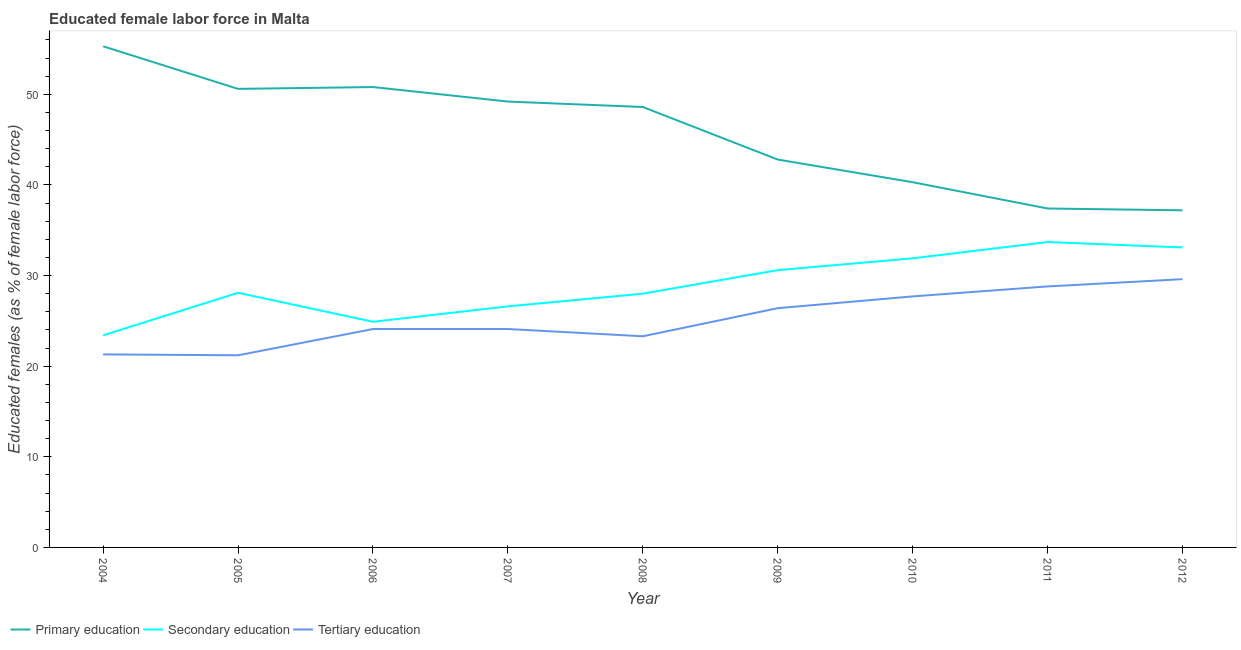Is the number of lines equal to the number of legend labels?
Your answer should be very brief. Yes. What is the percentage of female labor force who received tertiary education in 2010?
Give a very brief answer. 27.7. Across all years, what is the maximum percentage of female labor force who received primary education?
Provide a succinct answer. 55.3. Across all years, what is the minimum percentage of female labor force who received tertiary education?
Make the answer very short. 21.2. In which year was the percentage of female labor force who received primary education maximum?
Keep it short and to the point. 2004. What is the total percentage of female labor force who received tertiary education in the graph?
Make the answer very short. 226.5. What is the difference between the percentage of female labor force who received tertiary education in 2005 and that in 2011?
Provide a succinct answer. -7.6. What is the difference between the percentage of female labor force who received primary education in 2010 and the percentage of female labor force who received tertiary education in 2006?
Give a very brief answer. 16.2. What is the average percentage of female labor force who received tertiary education per year?
Your answer should be very brief. 25.17. In the year 2006, what is the difference between the percentage of female labor force who received secondary education and percentage of female labor force who received tertiary education?
Offer a very short reply. 0.8. In how many years, is the percentage of female labor force who received secondary education greater than 42 %?
Your response must be concise. 0. What is the ratio of the percentage of female labor force who received primary education in 2004 to that in 2005?
Provide a succinct answer. 1.09. Is the difference between the percentage of female labor force who received primary education in 2004 and 2005 greater than the difference between the percentage of female labor force who received secondary education in 2004 and 2005?
Your response must be concise. Yes. What is the difference between the highest and the second highest percentage of female labor force who received primary education?
Ensure brevity in your answer.  4.5. What is the difference between the highest and the lowest percentage of female labor force who received secondary education?
Make the answer very short. 10.3. Is the sum of the percentage of female labor force who received primary education in 2004 and 2010 greater than the maximum percentage of female labor force who received tertiary education across all years?
Your response must be concise. Yes. Is it the case that in every year, the sum of the percentage of female labor force who received primary education and percentage of female labor force who received secondary education is greater than the percentage of female labor force who received tertiary education?
Make the answer very short. Yes. How many years are there in the graph?
Give a very brief answer. 9. What is the difference between two consecutive major ticks on the Y-axis?
Provide a short and direct response. 10. Does the graph contain any zero values?
Provide a succinct answer. No. Does the graph contain grids?
Give a very brief answer. No. How many legend labels are there?
Your response must be concise. 3. What is the title of the graph?
Provide a short and direct response. Educated female labor force in Malta. What is the label or title of the Y-axis?
Offer a very short reply. Educated females (as % of female labor force). What is the Educated females (as % of female labor force) in Primary education in 2004?
Offer a very short reply. 55.3. What is the Educated females (as % of female labor force) of Secondary education in 2004?
Ensure brevity in your answer.  23.4. What is the Educated females (as % of female labor force) of Tertiary education in 2004?
Provide a succinct answer. 21.3. What is the Educated females (as % of female labor force) in Primary education in 2005?
Your answer should be compact. 50.6. What is the Educated females (as % of female labor force) in Secondary education in 2005?
Provide a succinct answer. 28.1. What is the Educated females (as % of female labor force) in Tertiary education in 2005?
Provide a short and direct response. 21.2. What is the Educated females (as % of female labor force) in Primary education in 2006?
Make the answer very short. 50.8. What is the Educated females (as % of female labor force) of Secondary education in 2006?
Your answer should be very brief. 24.9. What is the Educated females (as % of female labor force) in Tertiary education in 2006?
Make the answer very short. 24.1. What is the Educated females (as % of female labor force) in Primary education in 2007?
Keep it short and to the point. 49.2. What is the Educated females (as % of female labor force) of Secondary education in 2007?
Offer a terse response. 26.6. What is the Educated females (as % of female labor force) of Tertiary education in 2007?
Your response must be concise. 24.1. What is the Educated females (as % of female labor force) of Primary education in 2008?
Provide a succinct answer. 48.6. What is the Educated females (as % of female labor force) of Tertiary education in 2008?
Give a very brief answer. 23.3. What is the Educated females (as % of female labor force) of Primary education in 2009?
Ensure brevity in your answer.  42.8. What is the Educated females (as % of female labor force) in Secondary education in 2009?
Offer a very short reply. 30.6. What is the Educated females (as % of female labor force) of Tertiary education in 2009?
Your answer should be compact. 26.4. What is the Educated females (as % of female labor force) of Primary education in 2010?
Offer a very short reply. 40.3. What is the Educated females (as % of female labor force) in Secondary education in 2010?
Provide a short and direct response. 31.9. What is the Educated females (as % of female labor force) of Tertiary education in 2010?
Provide a succinct answer. 27.7. What is the Educated females (as % of female labor force) of Primary education in 2011?
Offer a terse response. 37.4. What is the Educated females (as % of female labor force) in Secondary education in 2011?
Give a very brief answer. 33.7. What is the Educated females (as % of female labor force) of Tertiary education in 2011?
Provide a short and direct response. 28.8. What is the Educated females (as % of female labor force) of Primary education in 2012?
Keep it short and to the point. 37.2. What is the Educated females (as % of female labor force) of Secondary education in 2012?
Provide a short and direct response. 33.1. What is the Educated females (as % of female labor force) in Tertiary education in 2012?
Keep it short and to the point. 29.6. Across all years, what is the maximum Educated females (as % of female labor force) in Primary education?
Ensure brevity in your answer.  55.3. Across all years, what is the maximum Educated females (as % of female labor force) in Secondary education?
Offer a terse response. 33.7. Across all years, what is the maximum Educated females (as % of female labor force) of Tertiary education?
Your answer should be compact. 29.6. Across all years, what is the minimum Educated females (as % of female labor force) in Primary education?
Offer a very short reply. 37.2. Across all years, what is the minimum Educated females (as % of female labor force) in Secondary education?
Provide a succinct answer. 23.4. Across all years, what is the minimum Educated females (as % of female labor force) of Tertiary education?
Your answer should be compact. 21.2. What is the total Educated females (as % of female labor force) of Primary education in the graph?
Offer a terse response. 412.2. What is the total Educated females (as % of female labor force) of Secondary education in the graph?
Offer a very short reply. 260.3. What is the total Educated females (as % of female labor force) of Tertiary education in the graph?
Make the answer very short. 226.5. What is the difference between the Educated females (as % of female labor force) of Primary education in 2004 and that in 2005?
Your answer should be very brief. 4.7. What is the difference between the Educated females (as % of female labor force) in Secondary education in 2004 and that in 2005?
Your answer should be very brief. -4.7. What is the difference between the Educated females (as % of female labor force) of Tertiary education in 2004 and that in 2005?
Offer a terse response. 0.1. What is the difference between the Educated females (as % of female labor force) of Primary education in 2004 and that in 2006?
Offer a very short reply. 4.5. What is the difference between the Educated females (as % of female labor force) of Tertiary education in 2004 and that in 2006?
Your answer should be very brief. -2.8. What is the difference between the Educated females (as % of female labor force) in Primary education in 2004 and that in 2007?
Your answer should be very brief. 6.1. What is the difference between the Educated females (as % of female labor force) in Secondary education in 2004 and that in 2007?
Your answer should be very brief. -3.2. What is the difference between the Educated females (as % of female labor force) in Primary education in 2004 and that in 2009?
Provide a succinct answer. 12.5. What is the difference between the Educated females (as % of female labor force) of Secondary education in 2004 and that in 2011?
Give a very brief answer. -10.3. What is the difference between the Educated females (as % of female labor force) in Primary education in 2004 and that in 2012?
Ensure brevity in your answer.  18.1. What is the difference between the Educated females (as % of female labor force) of Secondary education in 2004 and that in 2012?
Provide a succinct answer. -9.7. What is the difference between the Educated females (as % of female labor force) of Tertiary education in 2004 and that in 2012?
Offer a terse response. -8.3. What is the difference between the Educated females (as % of female labor force) in Secondary education in 2005 and that in 2006?
Provide a succinct answer. 3.2. What is the difference between the Educated females (as % of female labor force) of Tertiary education in 2005 and that in 2007?
Make the answer very short. -2.9. What is the difference between the Educated females (as % of female labor force) in Tertiary education in 2005 and that in 2008?
Give a very brief answer. -2.1. What is the difference between the Educated females (as % of female labor force) of Primary education in 2005 and that in 2009?
Keep it short and to the point. 7.8. What is the difference between the Educated females (as % of female labor force) in Secondary education in 2005 and that in 2009?
Offer a very short reply. -2.5. What is the difference between the Educated females (as % of female labor force) in Tertiary education in 2005 and that in 2009?
Provide a succinct answer. -5.2. What is the difference between the Educated females (as % of female labor force) in Primary education in 2005 and that in 2010?
Keep it short and to the point. 10.3. What is the difference between the Educated females (as % of female labor force) of Secondary education in 2005 and that in 2010?
Your answer should be very brief. -3.8. What is the difference between the Educated females (as % of female labor force) of Tertiary education in 2005 and that in 2010?
Provide a short and direct response. -6.5. What is the difference between the Educated females (as % of female labor force) in Secondary education in 2005 and that in 2012?
Ensure brevity in your answer.  -5. What is the difference between the Educated females (as % of female labor force) of Secondary education in 2006 and that in 2007?
Your response must be concise. -1.7. What is the difference between the Educated females (as % of female labor force) of Secondary education in 2006 and that in 2009?
Give a very brief answer. -5.7. What is the difference between the Educated females (as % of female labor force) in Tertiary education in 2006 and that in 2009?
Ensure brevity in your answer.  -2.3. What is the difference between the Educated females (as % of female labor force) in Primary education in 2006 and that in 2010?
Provide a short and direct response. 10.5. What is the difference between the Educated females (as % of female labor force) in Secondary education in 2006 and that in 2011?
Offer a very short reply. -8.8. What is the difference between the Educated females (as % of female labor force) in Tertiary education in 2006 and that in 2011?
Provide a succinct answer. -4.7. What is the difference between the Educated females (as % of female labor force) of Secondary education in 2006 and that in 2012?
Provide a succinct answer. -8.2. What is the difference between the Educated females (as % of female labor force) in Tertiary education in 2006 and that in 2012?
Give a very brief answer. -5.5. What is the difference between the Educated females (as % of female labor force) in Primary education in 2007 and that in 2008?
Your answer should be compact. 0.6. What is the difference between the Educated females (as % of female labor force) in Primary education in 2007 and that in 2009?
Keep it short and to the point. 6.4. What is the difference between the Educated females (as % of female labor force) in Secondary education in 2007 and that in 2009?
Offer a terse response. -4. What is the difference between the Educated females (as % of female labor force) of Tertiary education in 2007 and that in 2009?
Keep it short and to the point. -2.3. What is the difference between the Educated females (as % of female labor force) of Primary education in 2007 and that in 2010?
Make the answer very short. 8.9. What is the difference between the Educated females (as % of female labor force) of Tertiary education in 2007 and that in 2010?
Offer a very short reply. -3.6. What is the difference between the Educated females (as % of female labor force) of Secondary education in 2007 and that in 2011?
Provide a succinct answer. -7.1. What is the difference between the Educated females (as % of female labor force) of Tertiary education in 2007 and that in 2011?
Make the answer very short. -4.7. What is the difference between the Educated females (as % of female labor force) of Primary education in 2007 and that in 2012?
Your answer should be very brief. 12. What is the difference between the Educated females (as % of female labor force) of Secondary education in 2007 and that in 2012?
Offer a very short reply. -6.5. What is the difference between the Educated females (as % of female labor force) in Primary education in 2008 and that in 2009?
Provide a succinct answer. 5.8. What is the difference between the Educated females (as % of female labor force) in Secondary education in 2008 and that in 2009?
Your response must be concise. -2.6. What is the difference between the Educated females (as % of female labor force) in Secondary education in 2008 and that in 2011?
Offer a terse response. -5.7. What is the difference between the Educated females (as % of female labor force) of Tertiary education in 2008 and that in 2011?
Give a very brief answer. -5.5. What is the difference between the Educated females (as % of female labor force) in Tertiary education in 2008 and that in 2012?
Keep it short and to the point. -6.3. What is the difference between the Educated females (as % of female labor force) of Secondary education in 2009 and that in 2010?
Your answer should be compact. -1.3. What is the difference between the Educated females (as % of female labor force) of Primary education in 2009 and that in 2012?
Your response must be concise. 5.6. What is the difference between the Educated females (as % of female labor force) of Secondary education in 2009 and that in 2012?
Provide a succinct answer. -2.5. What is the difference between the Educated females (as % of female labor force) of Tertiary education in 2009 and that in 2012?
Offer a very short reply. -3.2. What is the difference between the Educated females (as % of female labor force) of Tertiary education in 2010 and that in 2011?
Offer a terse response. -1.1. What is the difference between the Educated females (as % of female labor force) of Primary education in 2010 and that in 2012?
Ensure brevity in your answer.  3.1. What is the difference between the Educated females (as % of female labor force) in Secondary education in 2010 and that in 2012?
Offer a very short reply. -1.2. What is the difference between the Educated females (as % of female labor force) of Primary education in 2011 and that in 2012?
Provide a short and direct response. 0.2. What is the difference between the Educated females (as % of female labor force) of Tertiary education in 2011 and that in 2012?
Offer a terse response. -0.8. What is the difference between the Educated females (as % of female labor force) in Primary education in 2004 and the Educated females (as % of female labor force) in Secondary education in 2005?
Your answer should be compact. 27.2. What is the difference between the Educated females (as % of female labor force) in Primary education in 2004 and the Educated females (as % of female labor force) in Tertiary education in 2005?
Your answer should be very brief. 34.1. What is the difference between the Educated females (as % of female labor force) of Primary education in 2004 and the Educated females (as % of female labor force) of Secondary education in 2006?
Your response must be concise. 30.4. What is the difference between the Educated females (as % of female labor force) of Primary education in 2004 and the Educated females (as % of female labor force) of Tertiary education in 2006?
Your answer should be very brief. 31.2. What is the difference between the Educated females (as % of female labor force) of Primary education in 2004 and the Educated females (as % of female labor force) of Secondary education in 2007?
Offer a terse response. 28.7. What is the difference between the Educated females (as % of female labor force) of Primary education in 2004 and the Educated females (as % of female labor force) of Tertiary education in 2007?
Keep it short and to the point. 31.2. What is the difference between the Educated females (as % of female labor force) in Primary education in 2004 and the Educated females (as % of female labor force) in Secondary education in 2008?
Your response must be concise. 27.3. What is the difference between the Educated females (as % of female labor force) of Primary education in 2004 and the Educated females (as % of female labor force) of Tertiary education in 2008?
Make the answer very short. 32. What is the difference between the Educated females (as % of female labor force) in Primary education in 2004 and the Educated females (as % of female labor force) in Secondary education in 2009?
Your answer should be very brief. 24.7. What is the difference between the Educated females (as % of female labor force) of Primary education in 2004 and the Educated females (as % of female labor force) of Tertiary education in 2009?
Make the answer very short. 28.9. What is the difference between the Educated females (as % of female labor force) in Primary education in 2004 and the Educated females (as % of female labor force) in Secondary education in 2010?
Your answer should be very brief. 23.4. What is the difference between the Educated females (as % of female labor force) in Primary education in 2004 and the Educated females (as % of female labor force) in Tertiary education in 2010?
Your answer should be very brief. 27.6. What is the difference between the Educated females (as % of female labor force) in Primary education in 2004 and the Educated females (as % of female labor force) in Secondary education in 2011?
Your response must be concise. 21.6. What is the difference between the Educated females (as % of female labor force) in Primary education in 2004 and the Educated females (as % of female labor force) in Tertiary education in 2011?
Your answer should be very brief. 26.5. What is the difference between the Educated females (as % of female labor force) in Primary education in 2004 and the Educated females (as % of female labor force) in Tertiary education in 2012?
Offer a very short reply. 25.7. What is the difference between the Educated females (as % of female labor force) in Secondary education in 2004 and the Educated females (as % of female labor force) in Tertiary education in 2012?
Offer a very short reply. -6.2. What is the difference between the Educated females (as % of female labor force) of Primary education in 2005 and the Educated females (as % of female labor force) of Secondary education in 2006?
Make the answer very short. 25.7. What is the difference between the Educated females (as % of female labor force) in Secondary education in 2005 and the Educated females (as % of female labor force) in Tertiary education in 2006?
Your response must be concise. 4. What is the difference between the Educated females (as % of female labor force) of Secondary education in 2005 and the Educated females (as % of female labor force) of Tertiary education in 2007?
Your response must be concise. 4. What is the difference between the Educated females (as % of female labor force) in Primary education in 2005 and the Educated females (as % of female labor force) in Secondary education in 2008?
Provide a succinct answer. 22.6. What is the difference between the Educated females (as % of female labor force) in Primary education in 2005 and the Educated females (as % of female labor force) in Tertiary education in 2008?
Your response must be concise. 27.3. What is the difference between the Educated females (as % of female labor force) of Secondary education in 2005 and the Educated females (as % of female labor force) of Tertiary education in 2008?
Ensure brevity in your answer.  4.8. What is the difference between the Educated females (as % of female labor force) in Primary education in 2005 and the Educated females (as % of female labor force) in Secondary education in 2009?
Your response must be concise. 20. What is the difference between the Educated females (as % of female labor force) in Primary education in 2005 and the Educated females (as % of female labor force) in Tertiary education in 2009?
Provide a short and direct response. 24.2. What is the difference between the Educated females (as % of female labor force) in Secondary education in 2005 and the Educated females (as % of female labor force) in Tertiary education in 2009?
Give a very brief answer. 1.7. What is the difference between the Educated females (as % of female labor force) in Primary education in 2005 and the Educated females (as % of female labor force) in Tertiary education in 2010?
Provide a succinct answer. 22.9. What is the difference between the Educated females (as % of female labor force) in Primary education in 2005 and the Educated females (as % of female labor force) in Tertiary education in 2011?
Keep it short and to the point. 21.8. What is the difference between the Educated females (as % of female labor force) in Secondary education in 2005 and the Educated females (as % of female labor force) in Tertiary education in 2011?
Provide a short and direct response. -0.7. What is the difference between the Educated females (as % of female labor force) of Secondary education in 2005 and the Educated females (as % of female labor force) of Tertiary education in 2012?
Offer a very short reply. -1.5. What is the difference between the Educated females (as % of female labor force) in Primary education in 2006 and the Educated females (as % of female labor force) in Secondary education in 2007?
Ensure brevity in your answer.  24.2. What is the difference between the Educated females (as % of female labor force) of Primary education in 2006 and the Educated females (as % of female labor force) of Tertiary education in 2007?
Your answer should be very brief. 26.7. What is the difference between the Educated females (as % of female labor force) in Secondary education in 2006 and the Educated females (as % of female labor force) in Tertiary education in 2007?
Offer a very short reply. 0.8. What is the difference between the Educated females (as % of female labor force) in Primary education in 2006 and the Educated females (as % of female labor force) in Secondary education in 2008?
Your answer should be very brief. 22.8. What is the difference between the Educated females (as % of female labor force) in Primary education in 2006 and the Educated females (as % of female labor force) in Tertiary education in 2008?
Provide a short and direct response. 27.5. What is the difference between the Educated females (as % of female labor force) in Primary education in 2006 and the Educated females (as % of female labor force) in Secondary education in 2009?
Your answer should be very brief. 20.2. What is the difference between the Educated females (as % of female labor force) of Primary education in 2006 and the Educated females (as % of female labor force) of Tertiary education in 2009?
Your answer should be very brief. 24.4. What is the difference between the Educated females (as % of female labor force) of Primary education in 2006 and the Educated females (as % of female labor force) of Tertiary education in 2010?
Ensure brevity in your answer.  23.1. What is the difference between the Educated females (as % of female labor force) in Secondary education in 2006 and the Educated females (as % of female labor force) in Tertiary education in 2011?
Your answer should be compact. -3.9. What is the difference between the Educated females (as % of female labor force) in Primary education in 2006 and the Educated females (as % of female labor force) in Secondary education in 2012?
Provide a short and direct response. 17.7. What is the difference between the Educated females (as % of female labor force) of Primary education in 2006 and the Educated females (as % of female labor force) of Tertiary education in 2012?
Make the answer very short. 21.2. What is the difference between the Educated females (as % of female labor force) of Primary education in 2007 and the Educated females (as % of female labor force) of Secondary education in 2008?
Provide a short and direct response. 21.2. What is the difference between the Educated females (as % of female labor force) in Primary education in 2007 and the Educated females (as % of female labor force) in Tertiary education in 2008?
Give a very brief answer. 25.9. What is the difference between the Educated females (as % of female labor force) of Primary education in 2007 and the Educated females (as % of female labor force) of Secondary education in 2009?
Your answer should be compact. 18.6. What is the difference between the Educated females (as % of female labor force) in Primary education in 2007 and the Educated females (as % of female labor force) in Tertiary education in 2009?
Your answer should be compact. 22.8. What is the difference between the Educated females (as % of female labor force) in Primary education in 2007 and the Educated females (as % of female labor force) in Secondary education in 2010?
Provide a short and direct response. 17.3. What is the difference between the Educated females (as % of female labor force) in Primary education in 2007 and the Educated females (as % of female labor force) in Secondary education in 2011?
Provide a succinct answer. 15.5. What is the difference between the Educated females (as % of female labor force) in Primary education in 2007 and the Educated females (as % of female labor force) in Tertiary education in 2011?
Offer a very short reply. 20.4. What is the difference between the Educated females (as % of female labor force) of Secondary education in 2007 and the Educated females (as % of female labor force) of Tertiary education in 2011?
Your response must be concise. -2.2. What is the difference between the Educated females (as % of female labor force) in Primary education in 2007 and the Educated females (as % of female labor force) in Tertiary education in 2012?
Provide a short and direct response. 19.6. What is the difference between the Educated females (as % of female labor force) in Primary education in 2008 and the Educated females (as % of female labor force) in Secondary education in 2009?
Your answer should be compact. 18. What is the difference between the Educated females (as % of female labor force) in Primary education in 2008 and the Educated females (as % of female labor force) in Tertiary education in 2009?
Provide a succinct answer. 22.2. What is the difference between the Educated females (as % of female labor force) of Primary education in 2008 and the Educated females (as % of female labor force) of Secondary education in 2010?
Your response must be concise. 16.7. What is the difference between the Educated females (as % of female labor force) in Primary education in 2008 and the Educated females (as % of female labor force) in Tertiary education in 2010?
Your answer should be compact. 20.9. What is the difference between the Educated females (as % of female labor force) of Secondary education in 2008 and the Educated females (as % of female labor force) of Tertiary education in 2010?
Your answer should be compact. 0.3. What is the difference between the Educated females (as % of female labor force) of Primary education in 2008 and the Educated females (as % of female labor force) of Secondary education in 2011?
Give a very brief answer. 14.9. What is the difference between the Educated females (as % of female labor force) of Primary education in 2008 and the Educated females (as % of female labor force) of Tertiary education in 2011?
Offer a very short reply. 19.8. What is the difference between the Educated females (as % of female labor force) of Secondary education in 2008 and the Educated females (as % of female labor force) of Tertiary education in 2011?
Give a very brief answer. -0.8. What is the difference between the Educated females (as % of female labor force) in Primary education in 2008 and the Educated females (as % of female labor force) in Secondary education in 2012?
Your answer should be compact. 15.5. What is the difference between the Educated females (as % of female labor force) in Primary education in 2009 and the Educated females (as % of female labor force) in Secondary education in 2010?
Your response must be concise. 10.9. What is the difference between the Educated females (as % of female labor force) of Primary education in 2009 and the Educated females (as % of female labor force) of Tertiary education in 2010?
Keep it short and to the point. 15.1. What is the difference between the Educated females (as % of female labor force) of Secondary education in 2009 and the Educated females (as % of female labor force) of Tertiary education in 2010?
Offer a terse response. 2.9. What is the difference between the Educated females (as % of female labor force) in Primary education in 2009 and the Educated females (as % of female labor force) in Secondary education in 2011?
Offer a very short reply. 9.1. What is the difference between the Educated females (as % of female labor force) of Primary education in 2009 and the Educated females (as % of female labor force) of Tertiary education in 2011?
Ensure brevity in your answer.  14. What is the difference between the Educated females (as % of female labor force) of Primary education in 2009 and the Educated females (as % of female labor force) of Secondary education in 2012?
Make the answer very short. 9.7. What is the difference between the Educated females (as % of female labor force) of Primary education in 2009 and the Educated females (as % of female labor force) of Tertiary education in 2012?
Your answer should be very brief. 13.2. What is the difference between the Educated females (as % of female labor force) in Secondary education in 2010 and the Educated females (as % of female labor force) in Tertiary education in 2011?
Your answer should be compact. 3.1. What is the difference between the Educated females (as % of female labor force) in Primary education in 2010 and the Educated females (as % of female labor force) in Secondary education in 2012?
Provide a short and direct response. 7.2. What is the difference between the Educated females (as % of female labor force) in Secondary education in 2011 and the Educated females (as % of female labor force) in Tertiary education in 2012?
Offer a very short reply. 4.1. What is the average Educated females (as % of female labor force) in Primary education per year?
Provide a succinct answer. 45.8. What is the average Educated females (as % of female labor force) of Secondary education per year?
Your answer should be very brief. 28.92. What is the average Educated females (as % of female labor force) in Tertiary education per year?
Make the answer very short. 25.17. In the year 2004, what is the difference between the Educated females (as % of female labor force) in Primary education and Educated females (as % of female labor force) in Secondary education?
Give a very brief answer. 31.9. In the year 2005, what is the difference between the Educated females (as % of female labor force) of Primary education and Educated females (as % of female labor force) of Secondary education?
Your answer should be compact. 22.5. In the year 2005, what is the difference between the Educated females (as % of female labor force) in Primary education and Educated females (as % of female labor force) in Tertiary education?
Your answer should be very brief. 29.4. In the year 2006, what is the difference between the Educated females (as % of female labor force) in Primary education and Educated females (as % of female labor force) in Secondary education?
Ensure brevity in your answer.  25.9. In the year 2006, what is the difference between the Educated females (as % of female labor force) of Primary education and Educated females (as % of female labor force) of Tertiary education?
Your answer should be very brief. 26.7. In the year 2006, what is the difference between the Educated females (as % of female labor force) of Secondary education and Educated females (as % of female labor force) of Tertiary education?
Make the answer very short. 0.8. In the year 2007, what is the difference between the Educated females (as % of female labor force) of Primary education and Educated females (as % of female labor force) of Secondary education?
Offer a very short reply. 22.6. In the year 2007, what is the difference between the Educated females (as % of female labor force) in Primary education and Educated females (as % of female labor force) in Tertiary education?
Offer a terse response. 25.1. In the year 2008, what is the difference between the Educated females (as % of female labor force) in Primary education and Educated females (as % of female labor force) in Secondary education?
Provide a succinct answer. 20.6. In the year 2008, what is the difference between the Educated females (as % of female labor force) of Primary education and Educated females (as % of female labor force) of Tertiary education?
Offer a very short reply. 25.3. In the year 2009, what is the difference between the Educated females (as % of female labor force) in Primary education and Educated females (as % of female labor force) in Secondary education?
Offer a terse response. 12.2. In the year 2009, what is the difference between the Educated females (as % of female labor force) in Primary education and Educated females (as % of female labor force) in Tertiary education?
Offer a very short reply. 16.4. In the year 2009, what is the difference between the Educated females (as % of female labor force) of Secondary education and Educated females (as % of female labor force) of Tertiary education?
Keep it short and to the point. 4.2. In the year 2010, what is the difference between the Educated females (as % of female labor force) of Primary education and Educated females (as % of female labor force) of Tertiary education?
Give a very brief answer. 12.6. In the year 2010, what is the difference between the Educated females (as % of female labor force) in Secondary education and Educated females (as % of female labor force) in Tertiary education?
Offer a very short reply. 4.2. In the year 2011, what is the difference between the Educated females (as % of female labor force) of Primary education and Educated females (as % of female labor force) of Tertiary education?
Offer a very short reply. 8.6. What is the ratio of the Educated females (as % of female labor force) of Primary education in 2004 to that in 2005?
Ensure brevity in your answer.  1.09. What is the ratio of the Educated females (as % of female labor force) of Secondary education in 2004 to that in 2005?
Ensure brevity in your answer.  0.83. What is the ratio of the Educated females (as % of female labor force) of Tertiary education in 2004 to that in 2005?
Your response must be concise. 1. What is the ratio of the Educated females (as % of female labor force) in Primary education in 2004 to that in 2006?
Your response must be concise. 1.09. What is the ratio of the Educated females (as % of female labor force) of Secondary education in 2004 to that in 2006?
Give a very brief answer. 0.94. What is the ratio of the Educated females (as % of female labor force) of Tertiary education in 2004 to that in 2006?
Your response must be concise. 0.88. What is the ratio of the Educated females (as % of female labor force) of Primary education in 2004 to that in 2007?
Your answer should be compact. 1.12. What is the ratio of the Educated females (as % of female labor force) in Secondary education in 2004 to that in 2007?
Provide a succinct answer. 0.88. What is the ratio of the Educated females (as % of female labor force) in Tertiary education in 2004 to that in 2007?
Ensure brevity in your answer.  0.88. What is the ratio of the Educated females (as % of female labor force) in Primary education in 2004 to that in 2008?
Your answer should be compact. 1.14. What is the ratio of the Educated females (as % of female labor force) in Secondary education in 2004 to that in 2008?
Offer a terse response. 0.84. What is the ratio of the Educated females (as % of female labor force) in Tertiary education in 2004 to that in 2008?
Provide a succinct answer. 0.91. What is the ratio of the Educated females (as % of female labor force) in Primary education in 2004 to that in 2009?
Your answer should be compact. 1.29. What is the ratio of the Educated females (as % of female labor force) of Secondary education in 2004 to that in 2009?
Provide a succinct answer. 0.76. What is the ratio of the Educated females (as % of female labor force) of Tertiary education in 2004 to that in 2009?
Offer a very short reply. 0.81. What is the ratio of the Educated females (as % of female labor force) in Primary education in 2004 to that in 2010?
Make the answer very short. 1.37. What is the ratio of the Educated females (as % of female labor force) of Secondary education in 2004 to that in 2010?
Keep it short and to the point. 0.73. What is the ratio of the Educated females (as % of female labor force) of Tertiary education in 2004 to that in 2010?
Make the answer very short. 0.77. What is the ratio of the Educated females (as % of female labor force) in Primary education in 2004 to that in 2011?
Your answer should be compact. 1.48. What is the ratio of the Educated females (as % of female labor force) of Secondary education in 2004 to that in 2011?
Give a very brief answer. 0.69. What is the ratio of the Educated females (as % of female labor force) in Tertiary education in 2004 to that in 2011?
Keep it short and to the point. 0.74. What is the ratio of the Educated females (as % of female labor force) of Primary education in 2004 to that in 2012?
Your response must be concise. 1.49. What is the ratio of the Educated females (as % of female labor force) in Secondary education in 2004 to that in 2012?
Your answer should be very brief. 0.71. What is the ratio of the Educated females (as % of female labor force) of Tertiary education in 2004 to that in 2012?
Your answer should be very brief. 0.72. What is the ratio of the Educated females (as % of female labor force) in Primary education in 2005 to that in 2006?
Ensure brevity in your answer.  1. What is the ratio of the Educated females (as % of female labor force) in Secondary education in 2005 to that in 2006?
Offer a very short reply. 1.13. What is the ratio of the Educated females (as % of female labor force) of Tertiary education in 2005 to that in 2006?
Keep it short and to the point. 0.88. What is the ratio of the Educated females (as % of female labor force) of Primary education in 2005 to that in 2007?
Keep it short and to the point. 1.03. What is the ratio of the Educated females (as % of female labor force) of Secondary education in 2005 to that in 2007?
Your answer should be compact. 1.06. What is the ratio of the Educated females (as % of female labor force) of Tertiary education in 2005 to that in 2007?
Ensure brevity in your answer.  0.88. What is the ratio of the Educated females (as % of female labor force) in Primary education in 2005 to that in 2008?
Offer a terse response. 1.04. What is the ratio of the Educated females (as % of female labor force) in Tertiary education in 2005 to that in 2008?
Your answer should be very brief. 0.91. What is the ratio of the Educated females (as % of female labor force) of Primary education in 2005 to that in 2009?
Provide a short and direct response. 1.18. What is the ratio of the Educated females (as % of female labor force) in Secondary education in 2005 to that in 2009?
Your response must be concise. 0.92. What is the ratio of the Educated females (as % of female labor force) in Tertiary education in 2005 to that in 2009?
Your answer should be very brief. 0.8. What is the ratio of the Educated females (as % of female labor force) of Primary education in 2005 to that in 2010?
Your answer should be compact. 1.26. What is the ratio of the Educated females (as % of female labor force) of Secondary education in 2005 to that in 2010?
Ensure brevity in your answer.  0.88. What is the ratio of the Educated females (as % of female labor force) in Tertiary education in 2005 to that in 2010?
Your answer should be very brief. 0.77. What is the ratio of the Educated females (as % of female labor force) in Primary education in 2005 to that in 2011?
Make the answer very short. 1.35. What is the ratio of the Educated females (as % of female labor force) in Secondary education in 2005 to that in 2011?
Provide a short and direct response. 0.83. What is the ratio of the Educated females (as % of female labor force) of Tertiary education in 2005 to that in 2011?
Ensure brevity in your answer.  0.74. What is the ratio of the Educated females (as % of female labor force) in Primary education in 2005 to that in 2012?
Offer a very short reply. 1.36. What is the ratio of the Educated females (as % of female labor force) in Secondary education in 2005 to that in 2012?
Provide a succinct answer. 0.85. What is the ratio of the Educated females (as % of female labor force) of Tertiary education in 2005 to that in 2012?
Ensure brevity in your answer.  0.72. What is the ratio of the Educated females (as % of female labor force) of Primary education in 2006 to that in 2007?
Ensure brevity in your answer.  1.03. What is the ratio of the Educated females (as % of female labor force) of Secondary education in 2006 to that in 2007?
Ensure brevity in your answer.  0.94. What is the ratio of the Educated females (as % of female labor force) of Primary education in 2006 to that in 2008?
Keep it short and to the point. 1.05. What is the ratio of the Educated females (as % of female labor force) in Secondary education in 2006 to that in 2008?
Offer a very short reply. 0.89. What is the ratio of the Educated females (as % of female labor force) in Tertiary education in 2006 to that in 2008?
Your answer should be compact. 1.03. What is the ratio of the Educated females (as % of female labor force) of Primary education in 2006 to that in 2009?
Your response must be concise. 1.19. What is the ratio of the Educated females (as % of female labor force) in Secondary education in 2006 to that in 2009?
Provide a short and direct response. 0.81. What is the ratio of the Educated females (as % of female labor force) in Tertiary education in 2006 to that in 2009?
Make the answer very short. 0.91. What is the ratio of the Educated females (as % of female labor force) of Primary education in 2006 to that in 2010?
Give a very brief answer. 1.26. What is the ratio of the Educated females (as % of female labor force) in Secondary education in 2006 to that in 2010?
Offer a very short reply. 0.78. What is the ratio of the Educated females (as % of female labor force) in Tertiary education in 2006 to that in 2010?
Offer a terse response. 0.87. What is the ratio of the Educated females (as % of female labor force) in Primary education in 2006 to that in 2011?
Your answer should be compact. 1.36. What is the ratio of the Educated females (as % of female labor force) of Secondary education in 2006 to that in 2011?
Offer a very short reply. 0.74. What is the ratio of the Educated females (as % of female labor force) of Tertiary education in 2006 to that in 2011?
Give a very brief answer. 0.84. What is the ratio of the Educated females (as % of female labor force) in Primary education in 2006 to that in 2012?
Keep it short and to the point. 1.37. What is the ratio of the Educated females (as % of female labor force) of Secondary education in 2006 to that in 2012?
Ensure brevity in your answer.  0.75. What is the ratio of the Educated females (as % of female labor force) in Tertiary education in 2006 to that in 2012?
Keep it short and to the point. 0.81. What is the ratio of the Educated females (as % of female labor force) in Primary education in 2007 to that in 2008?
Ensure brevity in your answer.  1.01. What is the ratio of the Educated females (as % of female labor force) of Tertiary education in 2007 to that in 2008?
Offer a very short reply. 1.03. What is the ratio of the Educated females (as % of female labor force) of Primary education in 2007 to that in 2009?
Provide a succinct answer. 1.15. What is the ratio of the Educated females (as % of female labor force) in Secondary education in 2007 to that in 2009?
Offer a very short reply. 0.87. What is the ratio of the Educated females (as % of female labor force) of Tertiary education in 2007 to that in 2009?
Ensure brevity in your answer.  0.91. What is the ratio of the Educated females (as % of female labor force) of Primary education in 2007 to that in 2010?
Your answer should be compact. 1.22. What is the ratio of the Educated females (as % of female labor force) of Secondary education in 2007 to that in 2010?
Make the answer very short. 0.83. What is the ratio of the Educated females (as % of female labor force) in Tertiary education in 2007 to that in 2010?
Offer a very short reply. 0.87. What is the ratio of the Educated females (as % of female labor force) of Primary education in 2007 to that in 2011?
Your answer should be compact. 1.32. What is the ratio of the Educated females (as % of female labor force) of Secondary education in 2007 to that in 2011?
Offer a terse response. 0.79. What is the ratio of the Educated females (as % of female labor force) of Tertiary education in 2007 to that in 2011?
Give a very brief answer. 0.84. What is the ratio of the Educated females (as % of female labor force) in Primary education in 2007 to that in 2012?
Your answer should be very brief. 1.32. What is the ratio of the Educated females (as % of female labor force) of Secondary education in 2007 to that in 2012?
Offer a very short reply. 0.8. What is the ratio of the Educated females (as % of female labor force) in Tertiary education in 2007 to that in 2012?
Provide a succinct answer. 0.81. What is the ratio of the Educated females (as % of female labor force) in Primary education in 2008 to that in 2009?
Make the answer very short. 1.14. What is the ratio of the Educated females (as % of female labor force) of Secondary education in 2008 to that in 2009?
Your response must be concise. 0.92. What is the ratio of the Educated females (as % of female labor force) of Tertiary education in 2008 to that in 2009?
Provide a short and direct response. 0.88. What is the ratio of the Educated females (as % of female labor force) of Primary education in 2008 to that in 2010?
Offer a very short reply. 1.21. What is the ratio of the Educated females (as % of female labor force) of Secondary education in 2008 to that in 2010?
Offer a very short reply. 0.88. What is the ratio of the Educated females (as % of female labor force) in Tertiary education in 2008 to that in 2010?
Your answer should be very brief. 0.84. What is the ratio of the Educated females (as % of female labor force) of Primary education in 2008 to that in 2011?
Make the answer very short. 1.3. What is the ratio of the Educated females (as % of female labor force) of Secondary education in 2008 to that in 2011?
Offer a very short reply. 0.83. What is the ratio of the Educated females (as % of female labor force) of Tertiary education in 2008 to that in 2011?
Offer a terse response. 0.81. What is the ratio of the Educated females (as % of female labor force) of Primary education in 2008 to that in 2012?
Keep it short and to the point. 1.31. What is the ratio of the Educated females (as % of female labor force) in Secondary education in 2008 to that in 2012?
Your answer should be compact. 0.85. What is the ratio of the Educated females (as % of female labor force) of Tertiary education in 2008 to that in 2012?
Offer a terse response. 0.79. What is the ratio of the Educated females (as % of female labor force) in Primary education in 2009 to that in 2010?
Your answer should be very brief. 1.06. What is the ratio of the Educated females (as % of female labor force) of Secondary education in 2009 to that in 2010?
Your answer should be very brief. 0.96. What is the ratio of the Educated females (as % of female labor force) of Tertiary education in 2009 to that in 2010?
Offer a terse response. 0.95. What is the ratio of the Educated females (as % of female labor force) in Primary education in 2009 to that in 2011?
Give a very brief answer. 1.14. What is the ratio of the Educated females (as % of female labor force) of Secondary education in 2009 to that in 2011?
Offer a very short reply. 0.91. What is the ratio of the Educated females (as % of female labor force) in Tertiary education in 2009 to that in 2011?
Keep it short and to the point. 0.92. What is the ratio of the Educated females (as % of female labor force) in Primary education in 2009 to that in 2012?
Your answer should be very brief. 1.15. What is the ratio of the Educated females (as % of female labor force) of Secondary education in 2009 to that in 2012?
Keep it short and to the point. 0.92. What is the ratio of the Educated females (as % of female labor force) in Tertiary education in 2009 to that in 2012?
Offer a very short reply. 0.89. What is the ratio of the Educated females (as % of female labor force) in Primary education in 2010 to that in 2011?
Provide a succinct answer. 1.08. What is the ratio of the Educated females (as % of female labor force) in Secondary education in 2010 to that in 2011?
Offer a very short reply. 0.95. What is the ratio of the Educated females (as % of female labor force) of Tertiary education in 2010 to that in 2011?
Your answer should be very brief. 0.96. What is the ratio of the Educated females (as % of female labor force) of Secondary education in 2010 to that in 2012?
Provide a short and direct response. 0.96. What is the ratio of the Educated females (as % of female labor force) of Tertiary education in 2010 to that in 2012?
Your answer should be compact. 0.94. What is the ratio of the Educated females (as % of female labor force) of Primary education in 2011 to that in 2012?
Offer a terse response. 1.01. What is the ratio of the Educated females (as % of female labor force) in Secondary education in 2011 to that in 2012?
Provide a succinct answer. 1.02. What is the difference between the highest and the second highest Educated females (as % of female labor force) in Tertiary education?
Offer a terse response. 0.8. What is the difference between the highest and the lowest Educated females (as % of female labor force) of Primary education?
Ensure brevity in your answer.  18.1. 